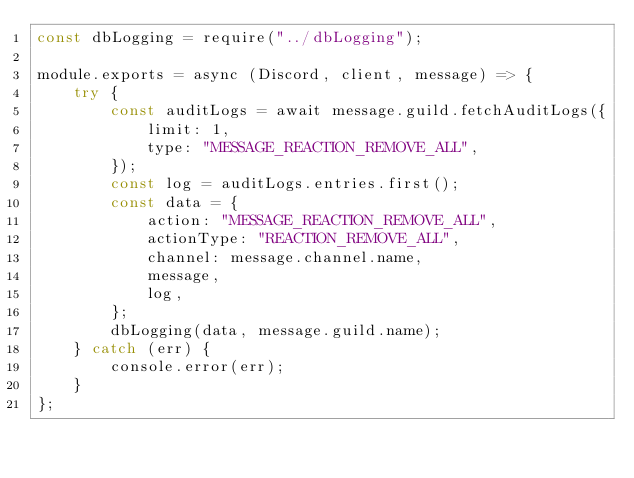<code> <loc_0><loc_0><loc_500><loc_500><_JavaScript_>const dbLogging = require("../dbLogging");

module.exports = async (Discord, client, message) => {
	try {
		const auditLogs = await message.guild.fetchAuditLogs({
			limit: 1,
			type: "MESSAGE_REACTION_REMOVE_ALL",
		});
		const log = auditLogs.entries.first();
		const data = {
			action: "MESSAGE_REACTION_REMOVE_ALL",
			actionType: "REACTION_REMOVE_ALL",
			channel: message.channel.name,
			message,
			log,
		};
		dbLogging(data, message.guild.name);
	} catch (err) {
		console.error(err);
	}
};
</code> 